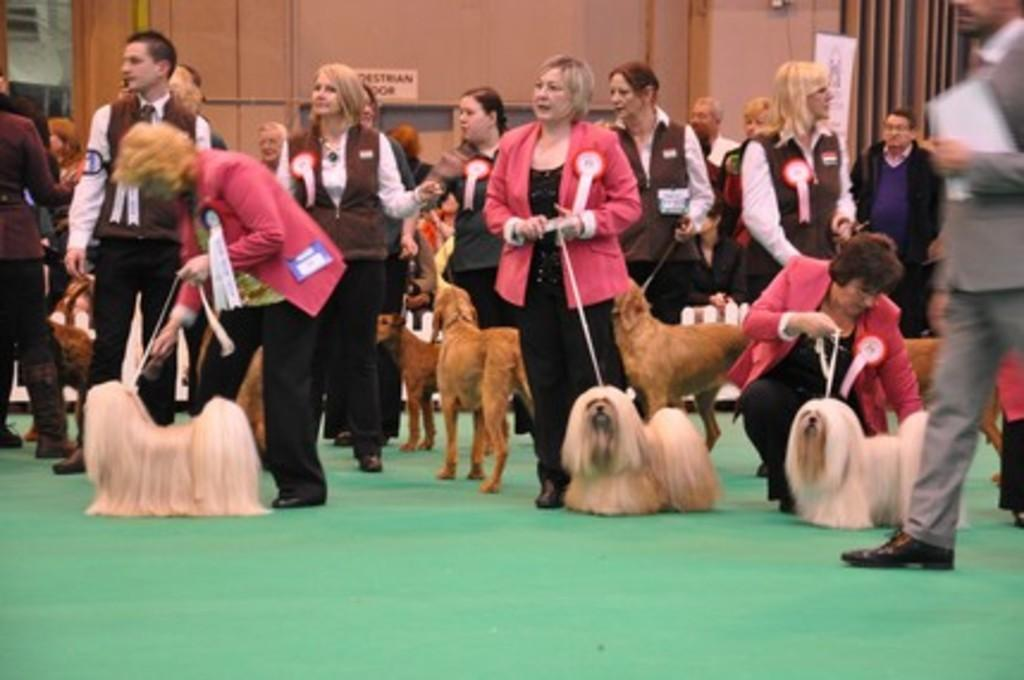How many people are in the image? There is a group of persons in the image. What are the persons holding in the image? The persons are holding thread. Where is the thread placed in the image? The thread is visible on a dog's neck. What can be seen on the wall in the image? There is a paper attached to the wall. What is the background of the image? The background of the image includes a wall. What type of wilderness can be seen in the image? There is no wilderness present in the image; it features a group of persons, a dog, a wall, and a paper. How many times does the thread twist around the dog's neck in the image? The number of twists in the thread around the dog's neck cannot be determined from the image. 